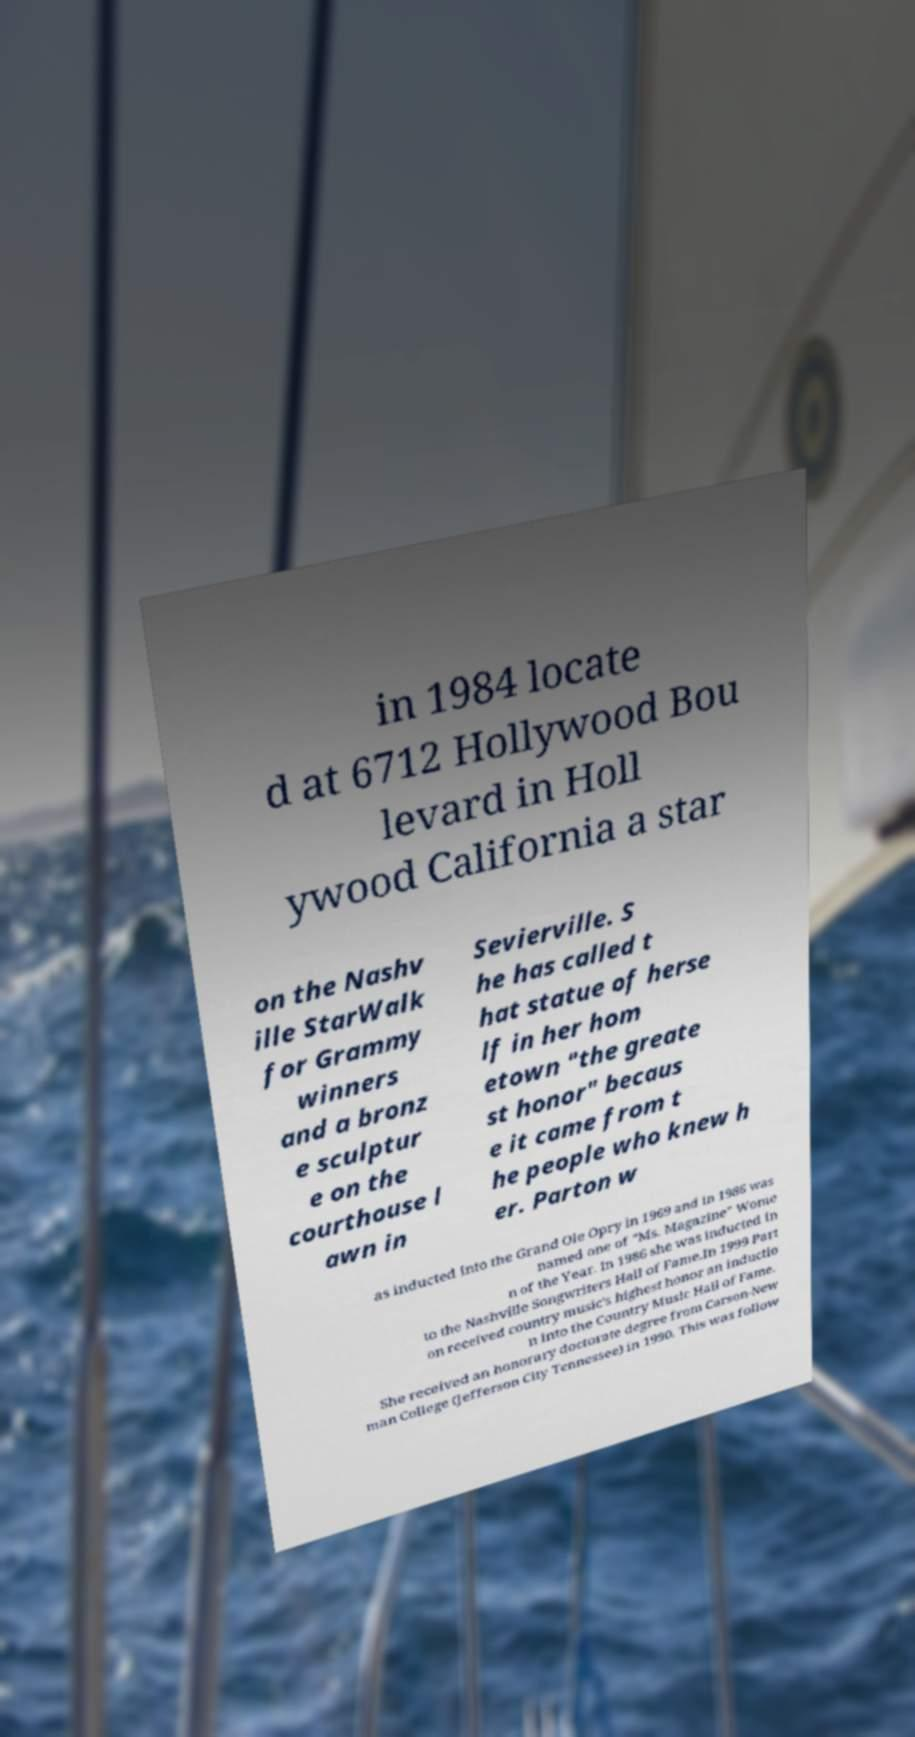Could you assist in decoding the text presented in this image and type it out clearly? in 1984 locate d at 6712 Hollywood Bou levard in Holl ywood California a star on the Nashv ille StarWalk for Grammy winners and a bronz e sculptur e on the courthouse l awn in Sevierville. S he has called t hat statue of herse lf in her hom etown "the greate st honor" becaus e it came from t he people who knew h er. Parton w as inducted into the Grand Ole Opry in 1969 and in 1986 was named one of "Ms. Magazine" Wome n of the Year. In 1986 she was inducted in to the Nashville Songwriters Hall of Fame.In 1999 Part on received country music's highest honor an inductio n into the Country Music Hall of Fame. She received an honorary doctorate degree from Carson-New man College (Jefferson City Tennessee) in 1990. This was follow 